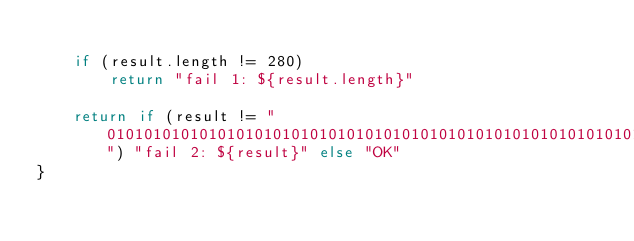Convert code to text. <code><loc_0><loc_0><loc_500><loc_500><_Kotlin_>
    if (result.length != 280)
        return "fail 1: ${result.length}"

    return if (result != "0101010101010101010101010101010101010101010101010101010101010101010101010101010101010101010101010101010101010101010101010101010101010101010101010101010101010101010101010101010101010101010101010101010101010101010101010101010101010101010101010101010101010101010101010101010101010101") "fail 2: ${result}" else "OK"
}</code> 